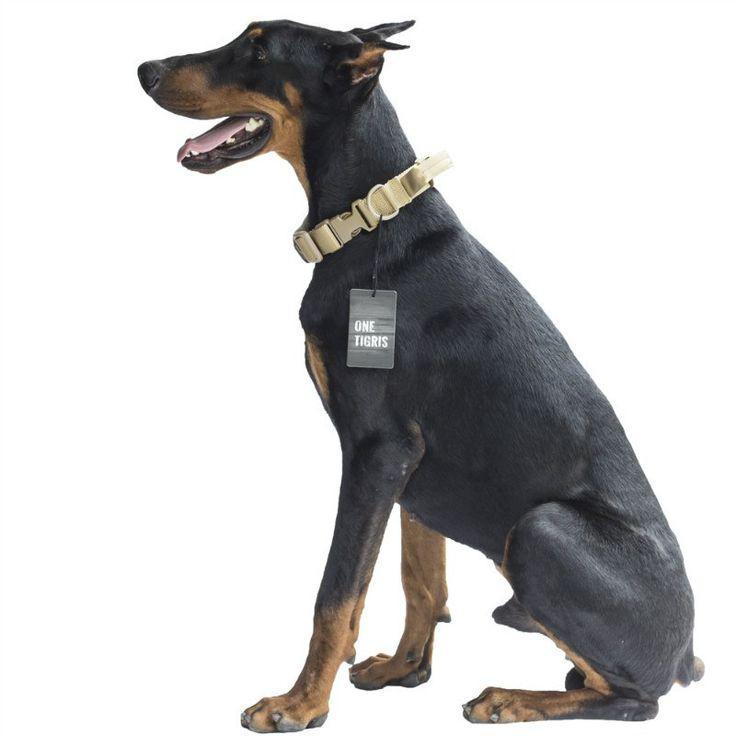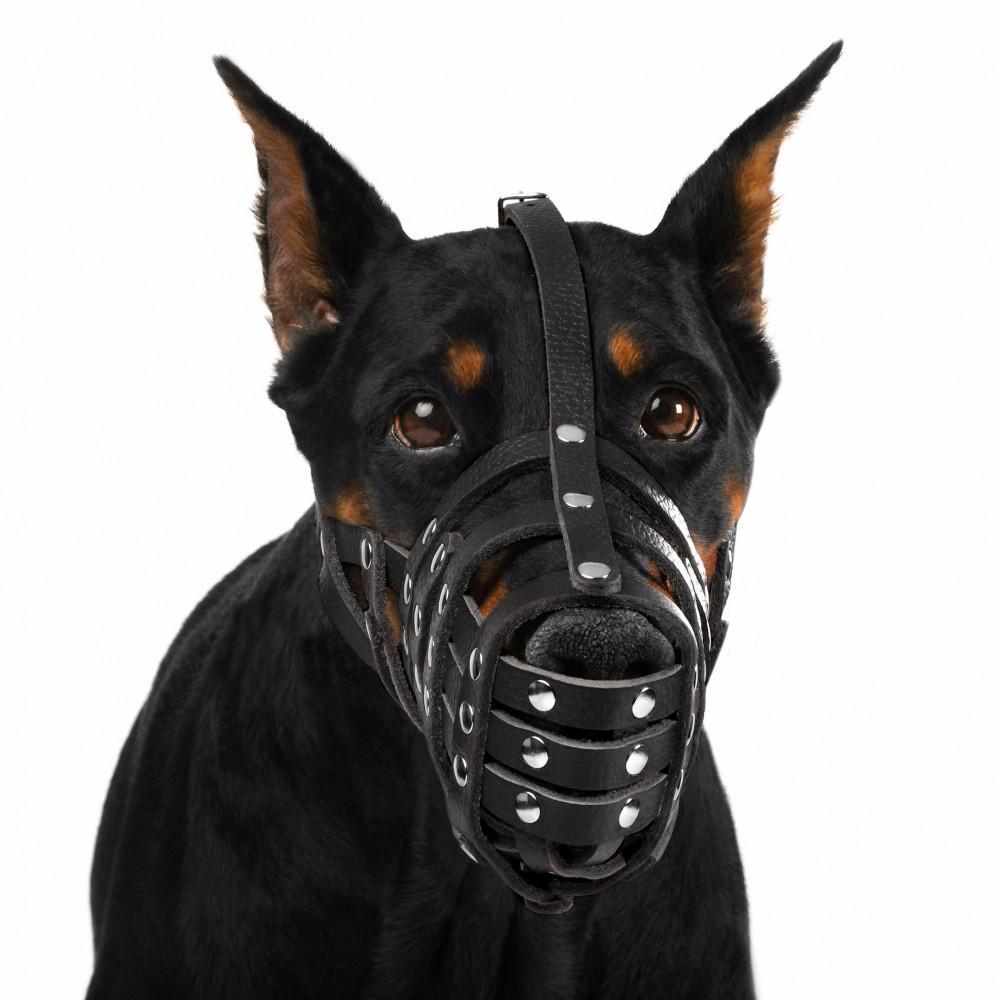The first image is the image on the left, the second image is the image on the right. Evaluate the accuracy of this statement regarding the images: "One of the dogs is wearing a muzzle.". Is it true? Answer yes or no. Yes. The first image is the image on the left, the second image is the image on the right. For the images displayed, is the sentence "Both images contain one dog that is attached the a leash." factually correct? Answer yes or no. No. 